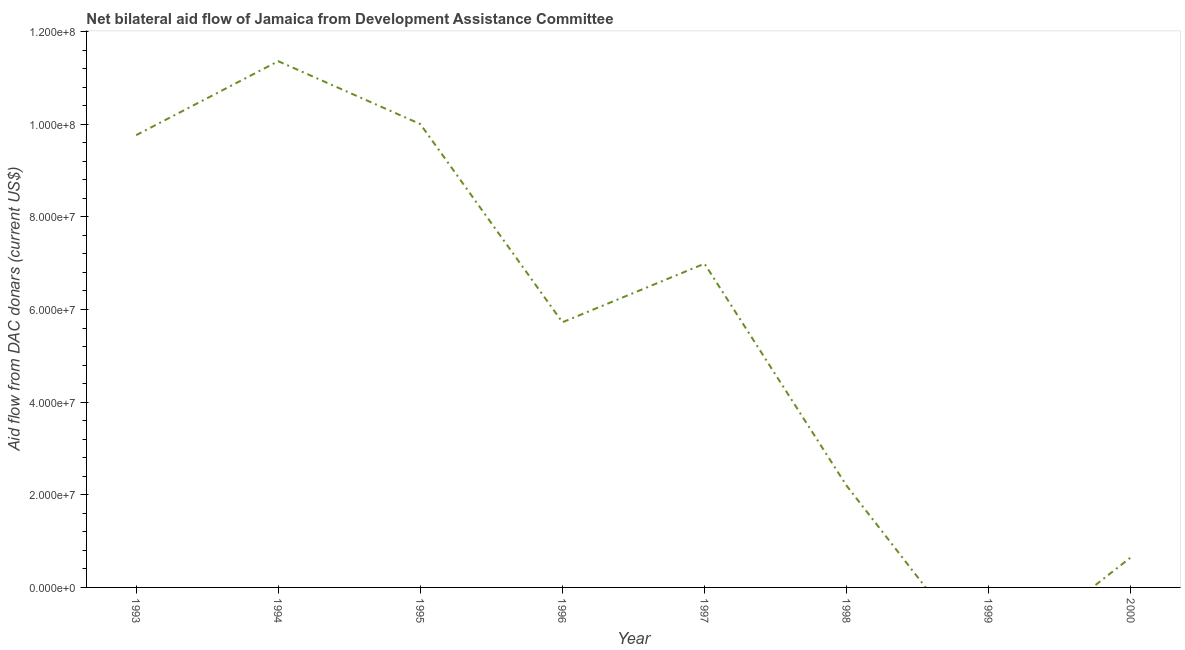What is the net bilateral aid flows from dac donors in 1997?
Provide a short and direct response. 6.99e+07. Across all years, what is the maximum net bilateral aid flows from dac donors?
Give a very brief answer. 1.14e+08. In which year was the net bilateral aid flows from dac donors maximum?
Give a very brief answer. 1994. What is the sum of the net bilateral aid flows from dac donors?
Ensure brevity in your answer.  4.67e+08. What is the difference between the net bilateral aid flows from dac donors in 1993 and 2000?
Provide a succinct answer. 9.12e+07. What is the average net bilateral aid flows from dac donors per year?
Make the answer very short. 5.84e+07. What is the median net bilateral aid flows from dac donors?
Give a very brief answer. 6.36e+07. In how many years, is the net bilateral aid flows from dac donors greater than 16000000 US$?
Provide a short and direct response. 6. What is the ratio of the net bilateral aid flows from dac donors in 1993 to that in 1996?
Provide a succinct answer. 1.71. Is the net bilateral aid flows from dac donors in 1995 less than that in 2000?
Give a very brief answer. No. What is the difference between the highest and the second highest net bilateral aid flows from dac donors?
Your answer should be compact. 1.36e+07. Is the sum of the net bilateral aid flows from dac donors in 1994 and 1996 greater than the maximum net bilateral aid flows from dac donors across all years?
Provide a succinct answer. Yes. What is the difference between the highest and the lowest net bilateral aid flows from dac donors?
Your answer should be compact. 1.14e+08. In how many years, is the net bilateral aid flows from dac donors greater than the average net bilateral aid flows from dac donors taken over all years?
Keep it short and to the point. 4. Does the net bilateral aid flows from dac donors monotonically increase over the years?
Ensure brevity in your answer.  No. How many lines are there?
Ensure brevity in your answer.  1. How many years are there in the graph?
Offer a very short reply. 8. Does the graph contain any zero values?
Provide a short and direct response. Yes. Does the graph contain grids?
Make the answer very short. No. What is the title of the graph?
Offer a terse response. Net bilateral aid flow of Jamaica from Development Assistance Committee. What is the label or title of the Y-axis?
Give a very brief answer. Aid flow from DAC donars (current US$). What is the Aid flow from DAC donars (current US$) of 1993?
Your answer should be very brief. 9.76e+07. What is the Aid flow from DAC donars (current US$) of 1994?
Offer a very short reply. 1.14e+08. What is the Aid flow from DAC donars (current US$) of 1995?
Your answer should be very brief. 1.00e+08. What is the Aid flow from DAC donars (current US$) in 1996?
Provide a succinct answer. 5.72e+07. What is the Aid flow from DAC donars (current US$) in 1997?
Provide a short and direct response. 6.99e+07. What is the Aid flow from DAC donars (current US$) of 1998?
Your answer should be compact. 2.20e+07. What is the Aid flow from DAC donars (current US$) in 2000?
Ensure brevity in your answer.  6.48e+06. What is the difference between the Aid flow from DAC donars (current US$) in 1993 and 1994?
Ensure brevity in your answer.  -1.60e+07. What is the difference between the Aid flow from DAC donars (current US$) in 1993 and 1995?
Your answer should be compact. -2.39e+06. What is the difference between the Aid flow from DAC donars (current US$) in 1993 and 1996?
Your answer should be very brief. 4.04e+07. What is the difference between the Aid flow from DAC donars (current US$) in 1993 and 1997?
Make the answer very short. 2.77e+07. What is the difference between the Aid flow from DAC donars (current US$) in 1993 and 1998?
Keep it short and to the point. 7.57e+07. What is the difference between the Aid flow from DAC donars (current US$) in 1993 and 2000?
Provide a succinct answer. 9.12e+07. What is the difference between the Aid flow from DAC donars (current US$) in 1994 and 1995?
Your response must be concise. 1.36e+07. What is the difference between the Aid flow from DAC donars (current US$) in 1994 and 1996?
Provide a succinct answer. 5.64e+07. What is the difference between the Aid flow from DAC donars (current US$) in 1994 and 1997?
Your answer should be compact. 4.37e+07. What is the difference between the Aid flow from DAC donars (current US$) in 1994 and 1998?
Provide a short and direct response. 9.16e+07. What is the difference between the Aid flow from DAC donars (current US$) in 1994 and 2000?
Your answer should be compact. 1.07e+08. What is the difference between the Aid flow from DAC donars (current US$) in 1995 and 1996?
Provide a succinct answer. 4.28e+07. What is the difference between the Aid flow from DAC donars (current US$) in 1995 and 1997?
Make the answer very short. 3.01e+07. What is the difference between the Aid flow from DAC donars (current US$) in 1995 and 1998?
Your response must be concise. 7.81e+07. What is the difference between the Aid flow from DAC donars (current US$) in 1995 and 2000?
Keep it short and to the point. 9.35e+07. What is the difference between the Aid flow from DAC donars (current US$) in 1996 and 1997?
Offer a terse response. -1.26e+07. What is the difference between the Aid flow from DAC donars (current US$) in 1996 and 1998?
Keep it short and to the point. 3.53e+07. What is the difference between the Aid flow from DAC donars (current US$) in 1996 and 2000?
Your response must be concise. 5.08e+07. What is the difference between the Aid flow from DAC donars (current US$) in 1997 and 1998?
Give a very brief answer. 4.79e+07. What is the difference between the Aid flow from DAC donars (current US$) in 1997 and 2000?
Provide a succinct answer. 6.34e+07. What is the difference between the Aid flow from DAC donars (current US$) in 1998 and 2000?
Provide a short and direct response. 1.55e+07. What is the ratio of the Aid flow from DAC donars (current US$) in 1993 to that in 1994?
Provide a short and direct response. 0.86. What is the ratio of the Aid flow from DAC donars (current US$) in 1993 to that in 1996?
Your answer should be very brief. 1.71. What is the ratio of the Aid flow from DAC donars (current US$) in 1993 to that in 1997?
Your answer should be compact. 1.4. What is the ratio of the Aid flow from DAC donars (current US$) in 1993 to that in 1998?
Your response must be concise. 4.45. What is the ratio of the Aid flow from DAC donars (current US$) in 1993 to that in 2000?
Provide a short and direct response. 15.07. What is the ratio of the Aid flow from DAC donars (current US$) in 1994 to that in 1995?
Keep it short and to the point. 1.14. What is the ratio of the Aid flow from DAC donars (current US$) in 1994 to that in 1996?
Offer a terse response. 1.99. What is the ratio of the Aid flow from DAC donars (current US$) in 1994 to that in 1997?
Keep it short and to the point. 1.62. What is the ratio of the Aid flow from DAC donars (current US$) in 1994 to that in 1998?
Provide a short and direct response. 5.17. What is the ratio of the Aid flow from DAC donars (current US$) in 1994 to that in 2000?
Your answer should be very brief. 17.53. What is the ratio of the Aid flow from DAC donars (current US$) in 1995 to that in 1996?
Offer a terse response. 1.75. What is the ratio of the Aid flow from DAC donars (current US$) in 1995 to that in 1997?
Your answer should be compact. 1.43. What is the ratio of the Aid flow from DAC donars (current US$) in 1995 to that in 1998?
Give a very brief answer. 4.55. What is the ratio of the Aid flow from DAC donars (current US$) in 1995 to that in 2000?
Provide a succinct answer. 15.44. What is the ratio of the Aid flow from DAC donars (current US$) in 1996 to that in 1997?
Provide a short and direct response. 0.82. What is the ratio of the Aid flow from DAC donars (current US$) in 1996 to that in 1998?
Your response must be concise. 2.61. What is the ratio of the Aid flow from DAC donars (current US$) in 1996 to that in 2000?
Provide a succinct answer. 8.83. What is the ratio of the Aid flow from DAC donars (current US$) in 1997 to that in 1998?
Give a very brief answer. 3.18. What is the ratio of the Aid flow from DAC donars (current US$) in 1997 to that in 2000?
Offer a terse response. 10.79. What is the ratio of the Aid flow from DAC donars (current US$) in 1998 to that in 2000?
Offer a terse response. 3.39. 